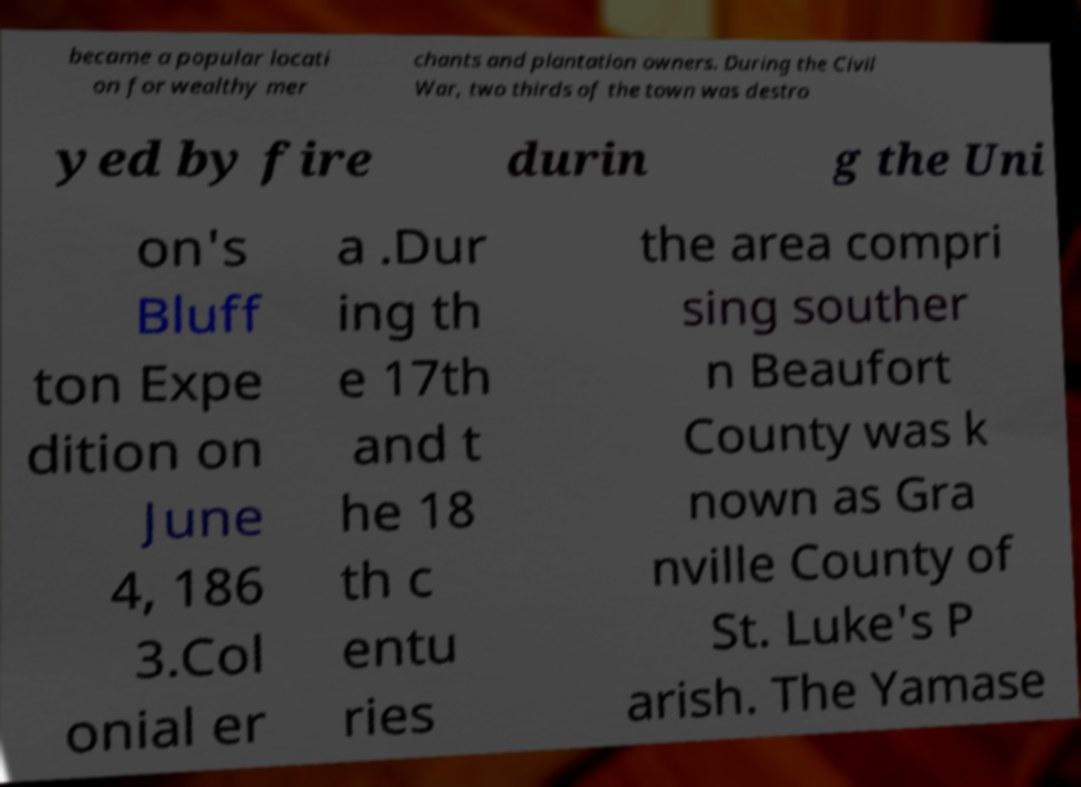What messages or text are displayed in this image? I need them in a readable, typed format. became a popular locati on for wealthy mer chants and plantation owners. During the Civil War, two thirds of the town was destro yed by fire durin g the Uni on's Bluff ton Expe dition on June 4, 186 3.Col onial er a .Dur ing th e 17th and t he 18 th c entu ries the area compri sing souther n Beaufort County was k nown as Gra nville County of St. Luke's P arish. The Yamase 